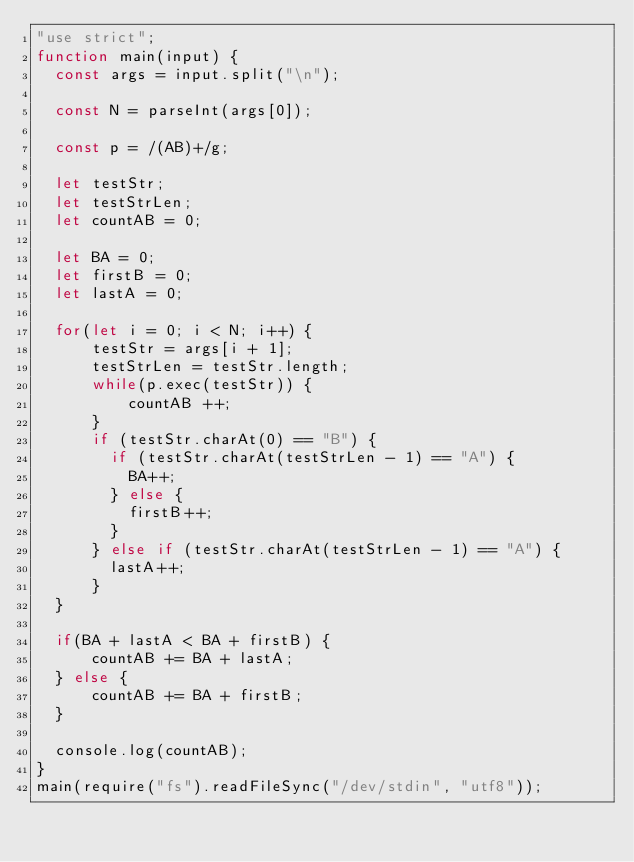<code> <loc_0><loc_0><loc_500><loc_500><_JavaScript_>"use strict";
function main(input) {
  const args = input.split("\n");

  const N = parseInt(args[0]);

  const p = /(AB)+/g;

  let testStr;
  let testStrLen;
  let countAB = 0;

  let BA = 0;
  let firstB = 0;
  let lastA = 0;

  for(let i = 0; i < N; i++) {
      testStr = args[i + 1];
      testStrLen = testStr.length;
      while(p.exec(testStr)) {
          countAB ++;
      }
      if (testStr.charAt(0) == "B") {
        if (testStr.charAt(testStrLen - 1) == "A") {
          BA++;
        } else {
          firstB++;
        }
      } else if (testStr.charAt(testStrLen - 1) == "A") {
        lastA++;
      }
  }

  if(BA + lastA < BA + firstB) {
      countAB += BA + lastA;
  } else {
      countAB += BA + firstB;
  }

  console.log(countAB);
}
main(require("fs").readFileSync("/dev/stdin", "utf8"));

</code> 